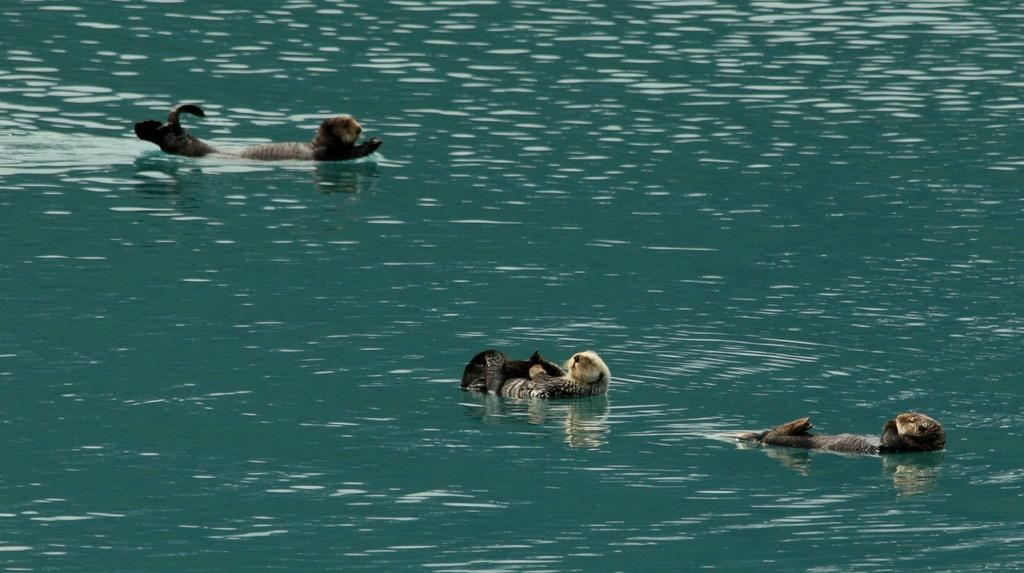What is happening on the surface of the water in the image? There are animals on the surface of the water in the image. What type of cable can be seen connecting the tomatoes in the image? There are no tomatoes or cables present in the image; it features animals on the surface of the water. 